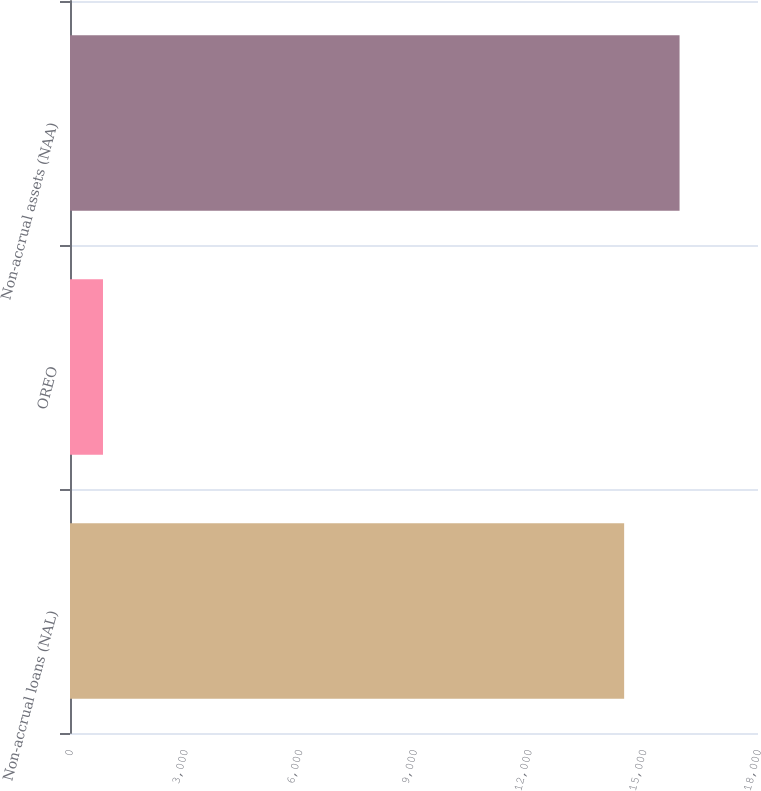Convert chart to OTSL. <chart><loc_0><loc_0><loc_500><loc_500><bar_chart><fcel>Non-accrual loans (NAL)<fcel>OREO<fcel>Non-accrual assets (NAA)<nl><fcel>14498<fcel>863<fcel>15947.8<nl></chart> 